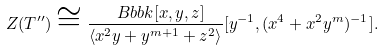Convert formula to latex. <formula><loc_0><loc_0><loc_500><loc_500>Z ( T ^ { \prime \prime } ) \cong \frac { \ B b b k [ x , y , z ] } { \langle x ^ { 2 } y + y ^ { m + 1 } + z ^ { 2 } \rangle } [ y ^ { - 1 } , ( x ^ { 4 } + x ^ { 2 } y ^ { m } ) ^ { - 1 } ] .</formula> 